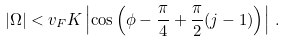Convert formula to latex. <formula><loc_0><loc_0><loc_500><loc_500>| \Omega | < v _ { F } K \left | \cos \left ( \phi - \frac { \pi } { 4 } + \frac { \pi } { 2 } ( j - 1 ) \right ) \right | \, .</formula> 